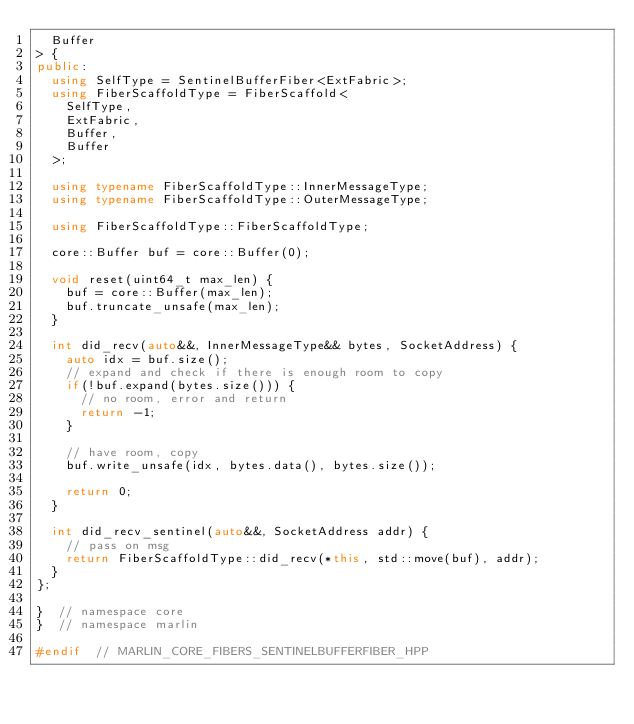Convert code to text. <code><loc_0><loc_0><loc_500><loc_500><_C++_>	Buffer
> {
public:
	using SelfType = SentinelBufferFiber<ExtFabric>;
	using FiberScaffoldType = FiberScaffold<
		SelfType,
		ExtFabric,
		Buffer,
		Buffer
	>;

	using typename FiberScaffoldType::InnerMessageType;
	using typename FiberScaffoldType::OuterMessageType;

	using FiberScaffoldType::FiberScaffoldType;

	core::Buffer buf = core::Buffer(0);

	void reset(uint64_t max_len) {
		buf = core::Buffer(max_len);
		buf.truncate_unsafe(max_len);
	}

	int did_recv(auto&&, InnerMessageType&& bytes, SocketAddress) {
		auto idx = buf.size();
		// expand and check if there is enough room to copy
		if(!buf.expand(bytes.size())) {
			// no room, error and return
			return -1;
		}

		// have room, copy
		buf.write_unsafe(idx, bytes.data(), bytes.size());

		return 0;
	}

	int did_recv_sentinel(auto&&, SocketAddress addr) {
		// pass on msg
		return FiberScaffoldType::did_recv(*this, std::move(buf), addr);
	}
};

}  // namespace core
}  // namespace marlin

#endif  // MARLIN_CORE_FIBERS_SENTINELBUFFERFIBER_HPP
</code> 